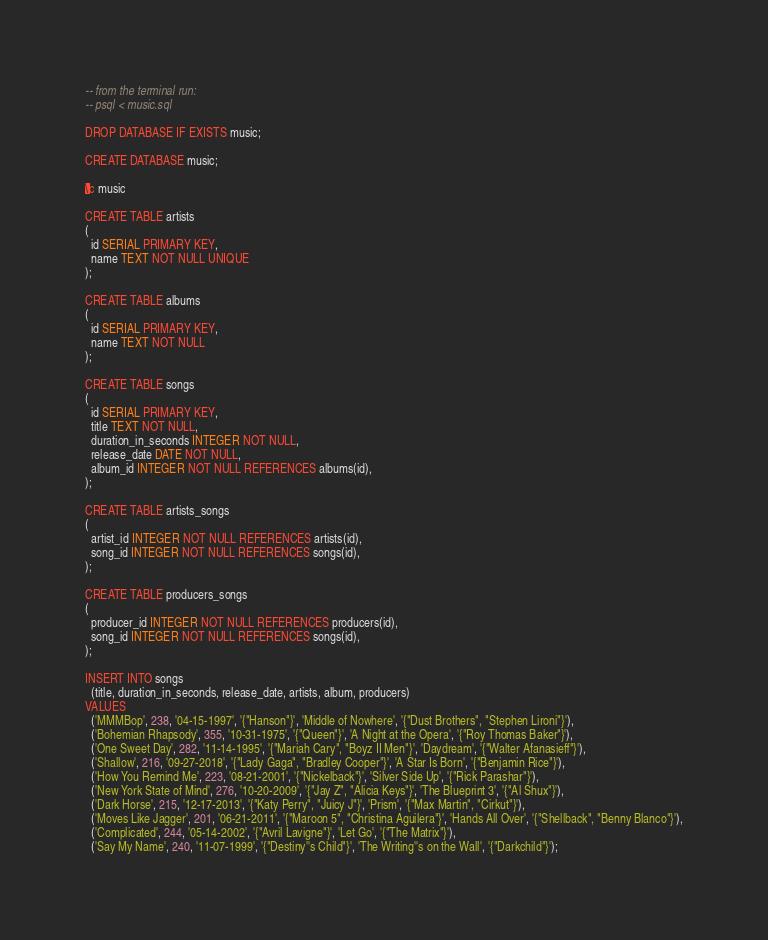<code> <loc_0><loc_0><loc_500><loc_500><_SQL_>-- from the terminal run:
-- psql < music.sql

DROP DATABASE IF EXISTS music;

CREATE DATABASE music;

\c music

CREATE TABLE artists
(
  id SERIAL PRIMARY KEY,
  name TEXT NOT NULL UNIQUE
);

CREATE TABLE albums
(
  id SERIAL PRIMARY KEY,
  name TEXT NOT NULL
);

CREATE TABLE songs
(
  id SERIAL PRIMARY KEY,
  title TEXT NOT NULL,
  duration_in_seconds INTEGER NOT NULL,
  release_date DATE NOT NULL,
  album_id INTEGER NOT NULL REFERENCES albums(id),
);

CREATE TABLE artists_songs
(
  artist_id INTEGER NOT NULL REFERENCES artists(id),
  song_id INTEGER NOT NULL REFERENCES songs(id),
);

CREATE TABLE producers_songs
(
  producer_id INTEGER NOT NULL REFERENCES producers(id),
  song_id INTEGER NOT NULL REFERENCES songs(id),
);

INSERT INTO songs
  (title, duration_in_seconds, release_date, artists, album, producers)
VALUES
  ('MMMBop', 238, '04-15-1997', '{"Hanson"}', 'Middle of Nowhere', '{"Dust Brothers", "Stephen Lironi"}'),
  ('Bohemian Rhapsody', 355, '10-31-1975', '{"Queen"}', 'A Night at the Opera', '{"Roy Thomas Baker"}'),
  ('One Sweet Day', 282, '11-14-1995', '{"Mariah Cary", "Boyz II Men"}', 'Daydream', '{"Walter Afanasieff"}'),
  ('Shallow', 216, '09-27-2018', '{"Lady Gaga", "Bradley Cooper"}', 'A Star Is Born', '{"Benjamin Rice"}'),
  ('How You Remind Me', 223, '08-21-2001', '{"Nickelback"}', 'Silver Side Up', '{"Rick Parashar"}'),
  ('New York State of Mind', 276, '10-20-2009', '{"Jay Z", "Alicia Keys"}', 'The Blueprint 3', '{"Al Shux"}'),
  ('Dark Horse', 215, '12-17-2013', '{"Katy Perry", "Juicy J"}', 'Prism', '{"Max Martin", "Cirkut"}'),
  ('Moves Like Jagger', 201, '06-21-2011', '{"Maroon 5", "Christina Aguilera"}', 'Hands All Over', '{"Shellback", "Benny Blanco"}'),
  ('Complicated', 244, '05-14-2002', '{"Avril Lavigne"}', 'Let Go', '{"The Matrix"}'),
  ('Say My Name', 240, '11-07-1999', '{"Destiny''s Child"}', 'The Writing''s on the Wall', '{"Darkchild"}');
</code> 